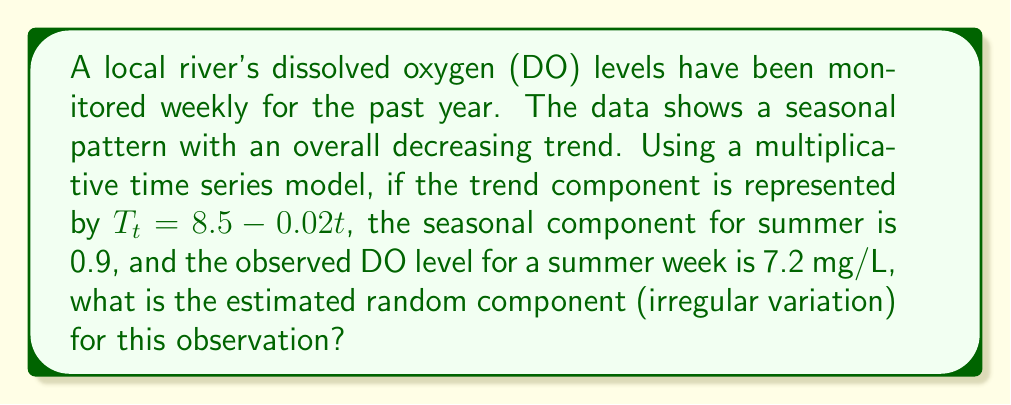Show me your answer to this math problem. To solve this problem, we'll use the multiplicative time series model:

$$O_t = T_t \times S_t \times I_t$$

Where:
$O_t$ = Observed value
$T_t$ = Trend component
$S_t$ = Seasonal component
$I_t$ = Irregular (random) component

We are given:
$O_t = 7.2$ mg/L (observed DO level)
$T_t = 8.5 - 0.02t$ (trend component)
$S_t = 0.9$ (seasonal component for summer)

Step 1: Determine the value of $t$.
Since we don't know the exact week, we'll use $t = 26$ (mid-year) for this example.

Step 2: Calculate the trend component $T_t$.
$$T_t = 8.5 - 0.02(26) = 8.5 - 0.52 = 7.98$$

Step 3: Use the multiplicative model to solve for $I_t$.
$$7.2 = 7.98 \times 0.9 \times I_t$$

Step 4: Isolate $I_t$.
$$I_t = \frac{7.2}{7.98 \times 0.9} = \frac{7.2}{7.182} \approx 1.0025$$

The irregular component is approximately 1.0025, indicating a slight positive deviation from the expected value based on trend and seasonality.
Answer: 1.0025 